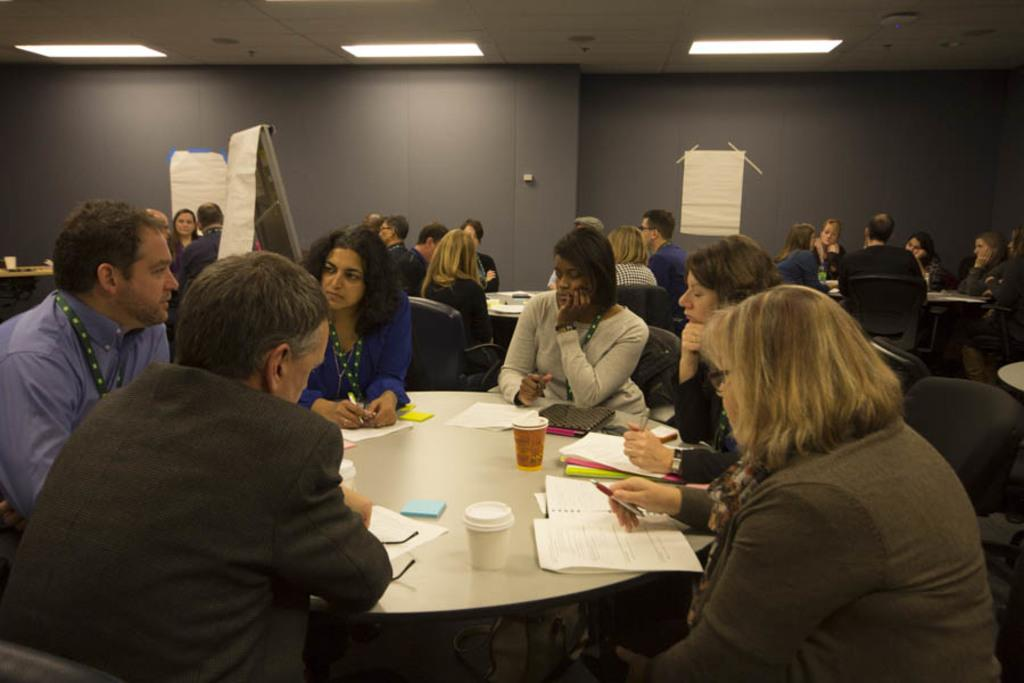What are the people in the image doing? The people in the image are sitting on chairs. What objects are on the table in the image? There are cups and papers on the table in the image. Can you describe the background of the image? There are additional tables visible in the background of the image. What type of copper material is present in the image? There is no copper material present in the image. What kind of meeting is taking place in the image? There is no indication of a meeting in the image; it simply shows people sitting on chairs with cups and papers on a table. 